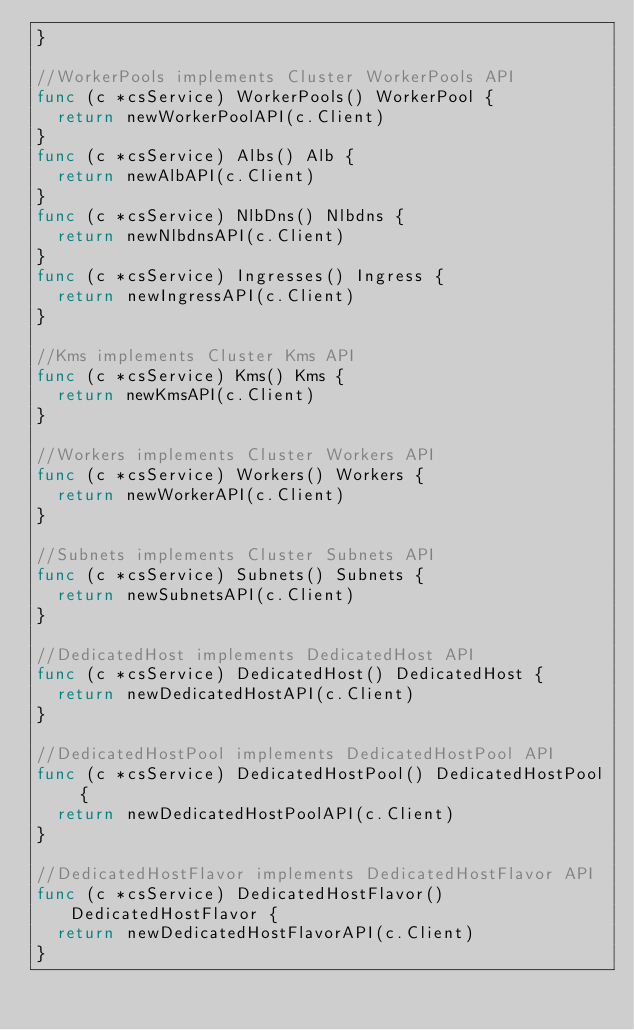Convert code to text. <code><loc_0><loc_0><loc_500><loc_500><_Go_>}

//WorkerPools implements Cluster WorkerPools API
func (c *csService) WorkerPools() WorkerPool {
	return newWorkerPoolAPI(c.Client)
}
func (c *csService) Albs() Alb {
	return newAlbAPI(c.Client)
}
func (c *csService) NlbDns() Nlbdns {
	return newNlbdnsAPI(c.Client)
}
func (c *csService) Ingresses() Ingress {
	return newIngressAPI(c.Client)
}

//Kms implements Cluster Kms API
func (c *csService) Kms() Kms {
	return newKmsAPI(c.Client)
}

//Workers implements Cluster Workers API
func (c *csService) Workers() Workers {
	return newWorkerAPI(c.Client)
}

//Subnets implements Cluster Subnets API
func (c *csService) Subnets() Subnets {
	return newSubnetsAPI(c.Client)
}

//DedicatedHost implements DedicatedHost API
func (c *csService) DedicatedHost() DedicatedHost {
	return newDedicatedHostAPI(c.Client)
}

//DedicatedHostPool implements DedicatedHostPool API
func (c *csService) DedicatedHostPool() DedicatedHostPool {
	return newDedicatedHostPoolAPI(c.Client)
}

//DedicatedHostFlavor implements DedicatedHostFlavor API
func (c *csService) DedicatedHostFlavor() DedicatedHostFlavor {
	return newDedicatedHostFlavorAPI(c.Client)
}
</code> 